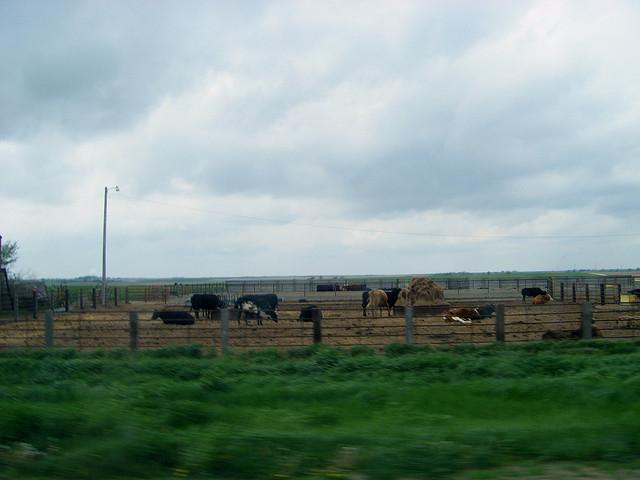How many mountains are there?
Give a very brief answer. 0. How many barns can be seen?
Give a very brief answer. 0. 